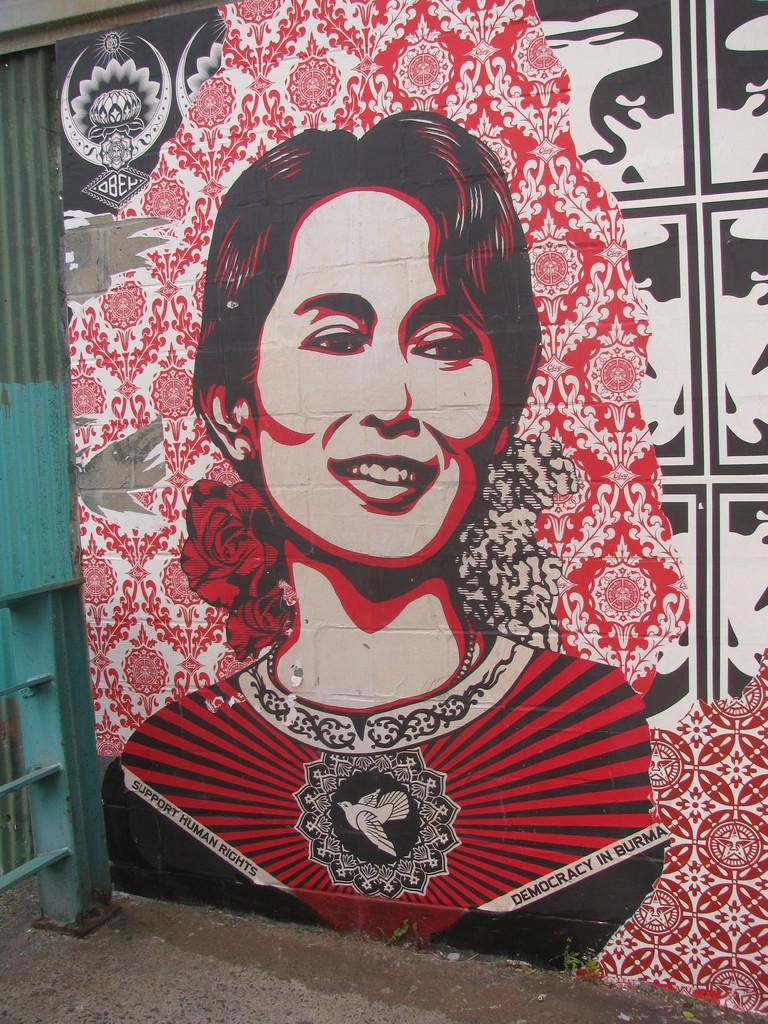What is the main subject of the image? The main subject of the image is a picture of a woman. Where is the picture of the woman located? The picture of the woman is on a board. What type of police officer is standing next to the icicle in the image? There is no police officer or icicle present in the image; it only features a picture of a woman on a board. 